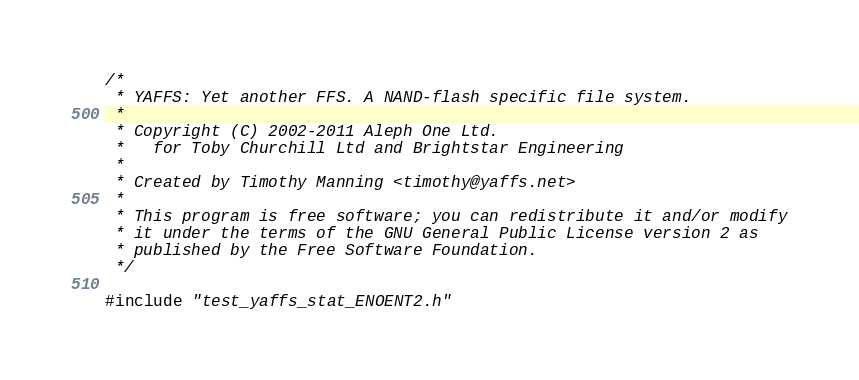<code> <loc_0><loc_0><loc_500><loc_500><_C_>/*
 * YAFFS: Yet another FFS. A NAND-flash specific file system.
 *
 * Copyright (C) 2002-2011 Aleph One Ltd.
 *   for Toby Churchill Ltd and Brightstar Engineering
 *
 * Created by Timothy Manning <timothy@yaffs.net>
 *
 * This program is free software; you can redistribute it and/or modify
 * it under the terms of the GNU General Public License version 2 as
 * published by the Free Software Foundation.
 */

#include "test_yaffs_stat_ENOENT2.h"
</code> 